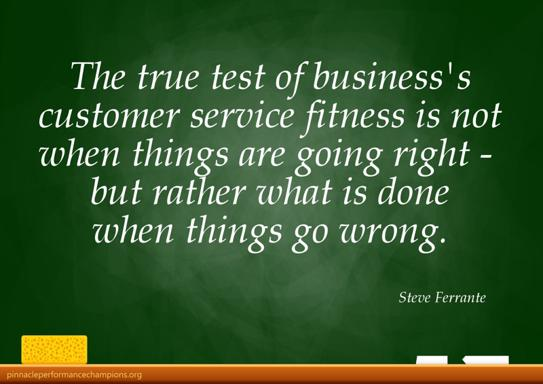How might the straightforward, unembellished style of the typography influence the reception of the message in the quote? The simple and clear typography style used in the quote ensures that the message is direct and easily understandable, echoing the importance of clarity and straightforwardness in communication within customer service. This unembellished style helps emphasize the sincerity and earnestness of the business's commitment to quality service during challenging times. 